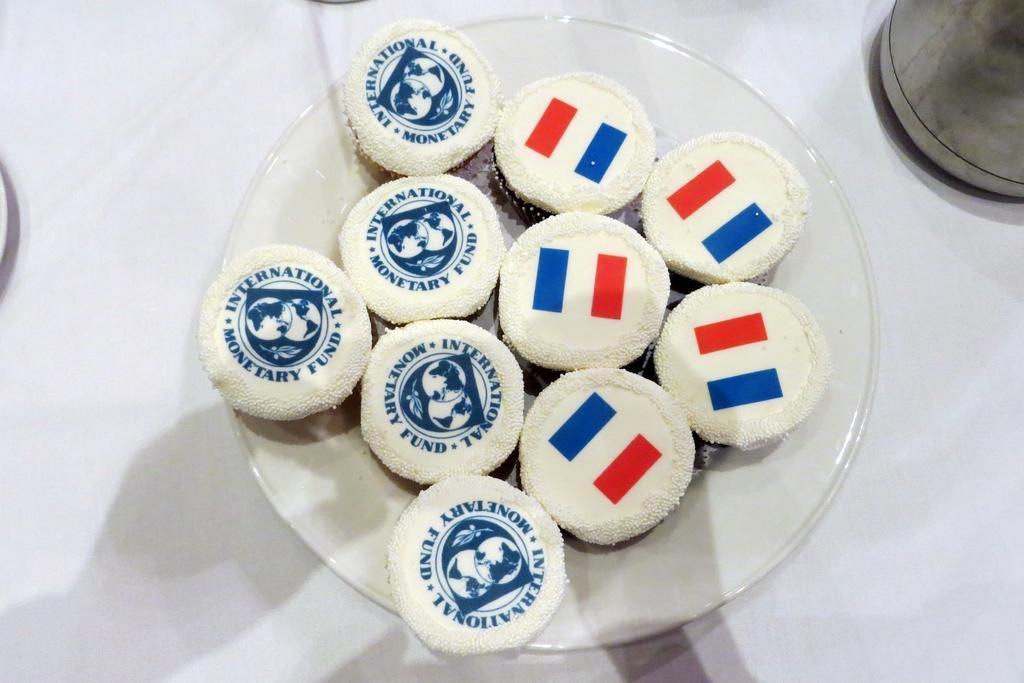Please provide a concise description of this image. In this image we can see cookies placed in a plate. 